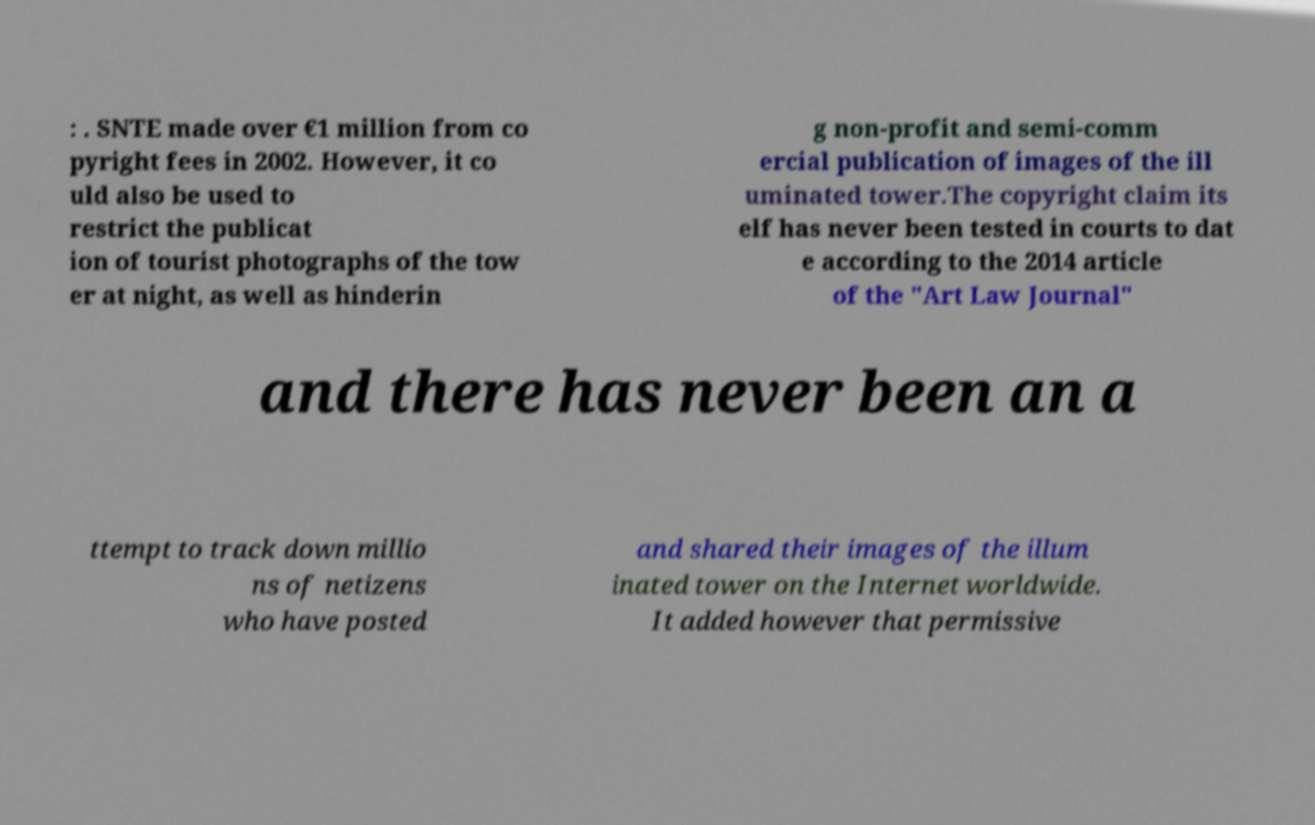Please read and relay the text visible in this image. What does it say? : . SNTE made over €1 million from co pyright fees in 2002. However, it co uld also be used to restrict the publicat ion of tourist photographs of the tow er at night, as well as hinderin g non-profit and semi-comm ercial publication of images of the ill uminated tower.The copyright claim its elf has never been tested in courts to dat e according to the 2014 article of the "Art Law Journal" and there has never been an a ttempt to track down millio ns of netizens who have posted and shared their images of the illum inated tower on the Internet worldwide. It added however that permissive 